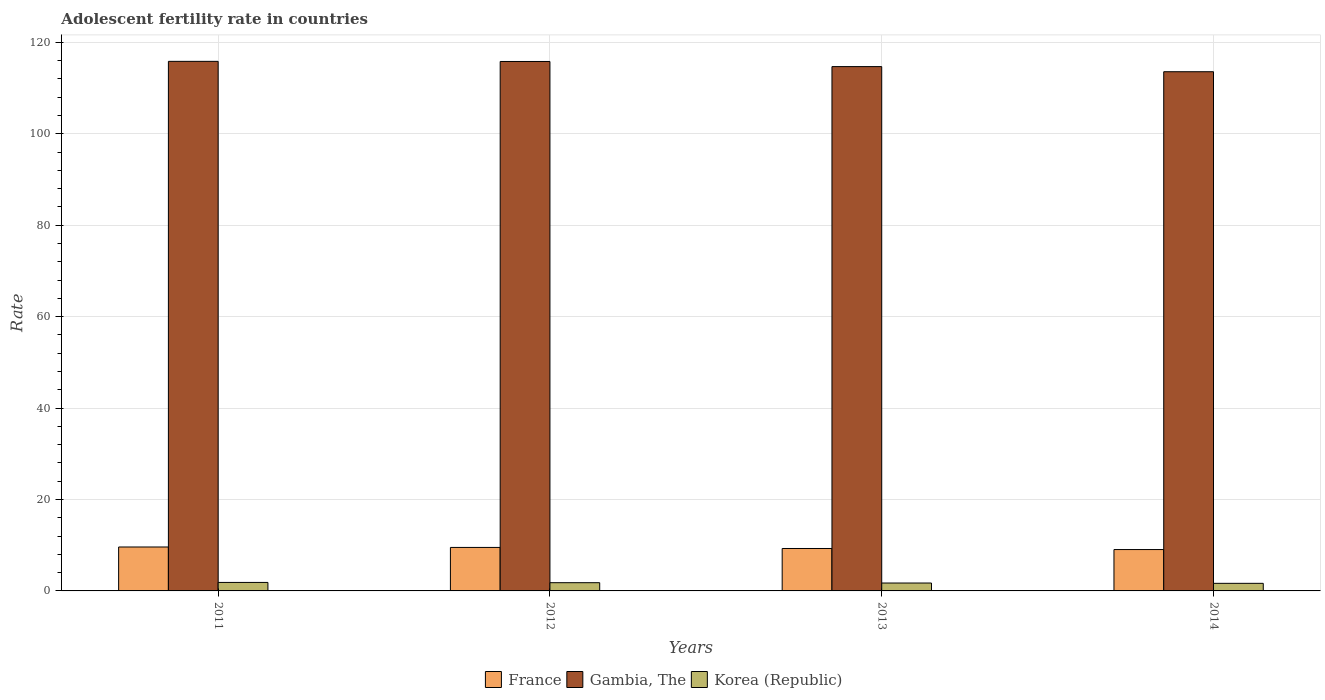How many different coloured bars are there?
Ensure brevity in your answer.  3. How many groups of bars are there?
Your answer should be compact. 4. Are the number of bars on each tick of the X-axis equal?
Ensure brevity in your answer.  Yes. What is the label of the 4th group of bars from the left?
Make the answer very short. 2014. What is the adolescent fertility rate in Gambia, The in 2014?
Offer a very short reply. 113.58. Across all years, what is the maximum adolescent fertility rate in Gambia, The?
Make the answer very short. 115.85. Across all years, what is the minimum adolescent fertility rate in Korea (Republic)?
Your response must be concise. 1.66. In which year was the adolescent fertility rate in France maximum?
Give a very brief answer. 2011. What is the total adolescent fertility rate in France in the graph?
Offer a very short reply. 37.46. What is the difference between the adolescent fertility rate in France in 2011 and that in 2012?
Provide a short and direct response. 0.1. What is the difference between the adolescent fertility rate in Korea (Republic) in 2012 and the adolescent fertility rate in France in 2013?
Your response must be concise. -7.48. What is the average adolescent fertility rate in Korea (Republic) per year?
Offer a very short reply. 1.76. In the year 2012, what is the difference between the adolescent fertility rate in Gambia, The and adolescent fertility rate in Korea (Republic)?
Your answer should be compact. 114.03. In how many years, is the adolescent fertility rate in France greater than 96?
Provide a short and direct response. 0. What is the ratio of the adolescent fertility rate in Korea (Republic) in 2012 to that in 2013?
Keep it short and to the point. 1.04. Is the difference between the adolescent fertility rate in Gambia, The in 2011 and 2013 greater than the difference between the adolescent fertility rate in Korea (Republic) in 2011 and 2013?
Offer a terse response. Yes. What is the difference between the highest and the second highest adolescent fertility rate in Korea (Republic)?
Provide a succinct answer. 0.06. What is the difference between the highest and the lowest adolescent fertility rate in Korea (Republic)?
Your answer should be compact. 0.2. In how many years, is the adolescent fertility rate in Korea (Republic) greater than the average adolescent fertility rate in Korea (Republic) taken over all years?
Give a very brief answer. 2. What does the 1st bar from the right in 2012 represents?
Your response must be concise. Korea (Republic). Are all the bars in the graph horizontal?
Your answer should be compact. No. How many years are there in the graph?
Provide a succinct answer. 4. What is the difference between two consecutive major ticks on the Y-axis?
Ensure brevity in your answer.  20. Does the graph contain any zero values?
Keep it short and to the point. No. Where does the legend appear in the graph?
Your answer should be very brief. Bottom center. How are the legend labels stacked?
Give a very brief answer. Horizontal. What is the title of the graph?
Your answer should be compact. Adolescent fertility rate in countries. What is the label or title of the Y-axis?
Your response must be concise. Rate. What is the Rate in France in 2011?
Your answer should be compact. 9.61. What is the Rate of Gambia, The in 2011?
Your response must be concise. 115.85. What is the Rate in Korea (Republic) in 2011?
Ensure brevity in your answer.  1.86. What is the Rate in France in 2012?
Offer a terse response. 9.52. What is the Rate in Gambia, The in 2012?
Provide a short and direct response. 115.82. What is the Rate in Korea (Republic) in 2012?
Provide a succinct answer. 1.8. What is the Rate of France in 2013?
Offer a very short reply. 9.28. What is the Rate of Gambia, The in 2013?
Offer a terse response. 114.7. What is the Rate in Korea (Republic) in 2013?
Your answer should be compact. 1.73. What is the Rate of France in 2014?
Ensure brevity in your answer.  9.05. What is the Rate in Gambia, The in 2014?
Your answer should be compact. 113.58. What is the Rate in Korea (Republic) in 2014?
Keep it short and to the point. 1.66. Across all years, what is the maximum Rate of France?
Offer a very short reply. 9.61. Across all years, what is the maximum Rate of Gambia, The?
Ensure brevity in your answer.  115.85. Across all years, what is the maximum Rate in Korea (Republic)?
Provide a succinct answer. 1.86. Across all years, what is the minimum Rate in France?
Make the answer very short. 9.05. Across all years, what is the minimum Rate in Gambia, The?
Provide a short and direct response. 113.58. Across all years, what is the minimum Rate in Korea (Republic)?
Your answer should be compact. 1.66. What is the total Rate of France in the graph?
Offer a very short reply. 37.46. What is the total Rate of Gambia, The in the graph?
Your response must be concise. 459.96. What is the total Rate of Korea (Republic) in the graph?
Provide a short and direct response. 7.04. What is the difference between the Rate in France in 2011 and that in 2012?
Give a very brief answer. 0.1. What is the difference between the Rate of Gambia, The in 2011 and that in 2012?
Provide a short and direct response. 0.03. What is the difference between the Rate in Korea (Republic) in 2011 and that in 2012?
Your answer should be compact. 0.06. What is the difference between the Rate in France in 2011 and that in 2013?
Offer a terse response. 0.33. What is the difference between the Rate in Gambia, The in 2011 and that in 2013?
Make the answer very short. 1.15. What is the difference between the Rate in Korea (Republic) in 2011 and that in 2013?
Offer a very short reply. 0.13. What is the difference between the Rate of France in 2011 and that in 2014?
Your response must be concise. 0.56. What is the difference between the Rate in Gambia, The in 2011 and that in 2014?
Ensure brevity in your answer.  2.27. What is the difference between the Rate in Korea (Republic) in 2011 and that in 2014?
Make the answer very short. 0.2. What is the difference between the Rate of France in 2012 and that in 2013?
Keep it short and to the point. 0.23. What is the difference between the Rate of Gambia, The in 2012 and that in 2013?
Offer a terse response. 1.12. What is the difference between the Rate of Korea (Republic) in 2012 and that in 2013?
Ensure brevity in your answer.  0.07. What is the difference between the Rate in France in 2012 and that in 2014?
Provide a succinct answer. 0.47. What is the difference between the Rate of Gambia, The in 2012 and that in 2014?
Give a very brief answer. 2.24. What is the difference between the Rate in Korea (Republic) in 2012 and that in 2014?
Provide a short and direct response. 0.14. What is the difference between the Rate of France in 2013 and that in 2014?
Offer a very short reply. 0.23. What is the difference between the Rate in Gambia, The in 2013 and that in 2014?
Ensure brevity in your answer.  1.12. What is the difference between the Rate in Korea (Republic) in 2013 and that in 2014?
Offer a very short reply. 0.07. What is the difference between the Rate of France in 2011 and the Rate of Gambia, The in 2012?
Give a very brief answer. -106.21. What is the difference between the Rate in France in 2011 and the Rate in Korea (Republic) in 2012?
Your response must be concise. 7.81. What is the difference between the Rate of Gambia, The in 2011 and the Rate of Korea (Republic) in 2012?
Your answer should be compact. 114.05. What is the difference between the Rate of France in 2011 and the Rate of Gambia, The in 2013?
Provide a short and direct response. -105.09. What is the difference between the Rate of France in 2011 and the Rate of Korea (Republic) in 2013?
Provide a short and direct response. 7.88. What is the difference between the Rate in Gambia, The in 2011 and the Rate in Korea (Republic) in 2013?
Give a very brief answer. 114.12. What is the difference between the Rate of France in 2011 and the Rate of Gambia, The in 2014?
Offer a very short reply. -103.97. What is the difference between the Rate in France in 2011 and the Rate in Korea (Republic) in 2014?
Provide a succinct answer. 7.95. What is the difference between the Rate in Gambia, The in 2011 and the Rate in Korea (Republic) in 2014?
Your answer should be compact. 114.19. What is the difference between the Rate of France in 2012 and the Rate of Gambia, The in 2013?
Offer a very short reply. -105.19. What is the difference between the Rate in France in 2012 and the Rate in Korea (Republic) in 2013?
Your answer should be very brief. 7.79. What is the difference between the Rate of Gambia, The in 2012 and the Rate of Korea (Republic) in 2013?
Offer a terse response. 114.1. What is the difference between the Rate in France in 2012 and the Rate in Gambia, The in 2014?
Provide a short and direct response. -104.07. What is the difference between the Rate of France in 2012 and the Rate of Korea (Republic) in 2014?
Keep it short and to the point. 7.86. What is the difference between the Rate of Gambia, The in 2012 and the Rate of Korea (Republic) in 2014?
Your response must be concise. 114.17. What is the difference between the Rate in France in 2013 and the Rate in Gambia, The in 2014?
Your response must be concise. -104.3. What is the difference between the Rate of France in 2013 and the Rate of Korea (Republic) in 2014?
Ensure brevity in your answer.  7.62. What is the difference between the Rate of Gambia, The in 2013 and the Rate of Korea (Republic) in 2014?
Ensure brevity in your answer.  113.05. What is the average Rate in France per year?
Ensure brevity in your answer.  9.36. What is the average Rate of Gambia, The per year?
Ensure brevity in your answer.  114.99. What is the average Rate in Korea (Republic) per year?
Offer a very short reply. 1.76. In the year 2011, what is the difference between the Rate of France and Rate of Gambia, The?
Keep it short and to the point. -106.24. In the year 2011, what is the difference between the Rate of France and Rate of Korea (Republic)?
Provide a succinct answer. 7.75. In the year 2011, what is the difference between the Rate of Gambia, The and Rate of Korea (Republic)?
Offer a very short reply. 114. In the year 2012, what is the difference between the Rate of France and Rate of Gambia, The?
Ensure brevity in your answer.  -106.31. In the year 2012, what is the difference between the Rate in France and Rate in Korea (Republic)?
Give a very brief answer. 7.72. In the year 2012, what is the difference between the Rate in Gambia, The and Rate in Korea (Republic)?
Provide a short and direct response. 114.03. In the year 2013, what is the difference between the Rate of France and Rate of Gambia, The?
Your answer should be compact. -105.42. In the year 2013, what is the difference between the Rate of France and Rate of Korea (Republic)?
Your answer should be compact. 7.55. In the year 2013, what is the difference between the Rate in Gambia, The and Rate in Korea (Republic)?
Your answer should be compact. 112.98. In the year 2014, what is the difference between the Rate of France and Rate of Gambia, The?
Keep it short and to the point. -104.54. In the year 2014, what is the difference between the Rate of France and Rate of Korea (Republic)?
Your response must be concise. 7.39. In the year 2014, what is the difference between the Rate of Gambia, The and Rate of Korea (Republic)?
Give a very brief answer. 111.93. What is the ratio of the Rate in France in 2011 to that in 2012?
Provide a short and direct response. 1.01. What is the ratio of the Rate in Korea (Republic) in 2011 to that in 2012?
Your response must be concise. 1.03. What is the ratio of the Rate in France in 2011 to that in 2013?
Keep it short and to the point. 1.04. What is the ratio of the Rate of Gambia, The in 2011 to that in 2013?
Give a very brief answer. 1.01. What is the ratio of the Rate of Korea (Republic) in 2011 to that in 2013?
Provide a succinct answer. 1.07. What is the ratio of the Rate in France in 2011 to that in 2014?
Give a very brief answer. 1.06. What is the ratio of the Rate of Korea (Republic) in 2011 to that in 2014?
Provide a short and direct response. 1.12. What is the ratio of the Rate of France in 2012 to that in 2013?
Offer a very short reply. 1.03. What is the ratio of the Rate of Gambia, The in 2012 to that in 2013?
Your response must be concise. 1.01. What is the ratio of the Rate of Korea (Republic) in 2012 to that in 2013?
Your answer should be very brief. 1.04. What is the ratio of the Rate in France in 2012 to that in 2014?
Provide a succinct answer. 1.05. What is the ratio of the Rate of Gambia, The in 2012 to that in 2014?
Keep it short and to the point. 1.02. What is the ratio of the Rate of Korea (Republic) in 2012 to that in 2014?
Provide a short and direct response. 1.08. What is the ratio of the Rate of France in 2013 to that in 2014?
Your answer should be very brief. 1.03. What is the ratio of the Rate in Gambia, The in 2013 to that in 2014?
Your response must be concise. 1.01. What is the ratio of the Rate of Korea (Republic) in 2013 to that in 2014?
Provide a short and direct response. 1.04. What is the difference between the highest and the second highest Rate in France?
Your response must be concise. 0.1. What is the difference between the highest and the second highest Rate of Gambia, The?
Your response must be concise. 0.03. What is the difference between the highest and the second highest Rate in Korea (Republic)?
Offer a very short reply. 0.06. What is the difference between the highest and the lowest Rate of France?
Provide a short and direct response. 0.56. What is the difference between the highest and the lowest Rate in Gambia, The?
Ensure brevity in your answer.  2.27. What is the difference between the highest and the lowest Rate of Korea (Republic)?
Your answer should be compact. 0.2. 